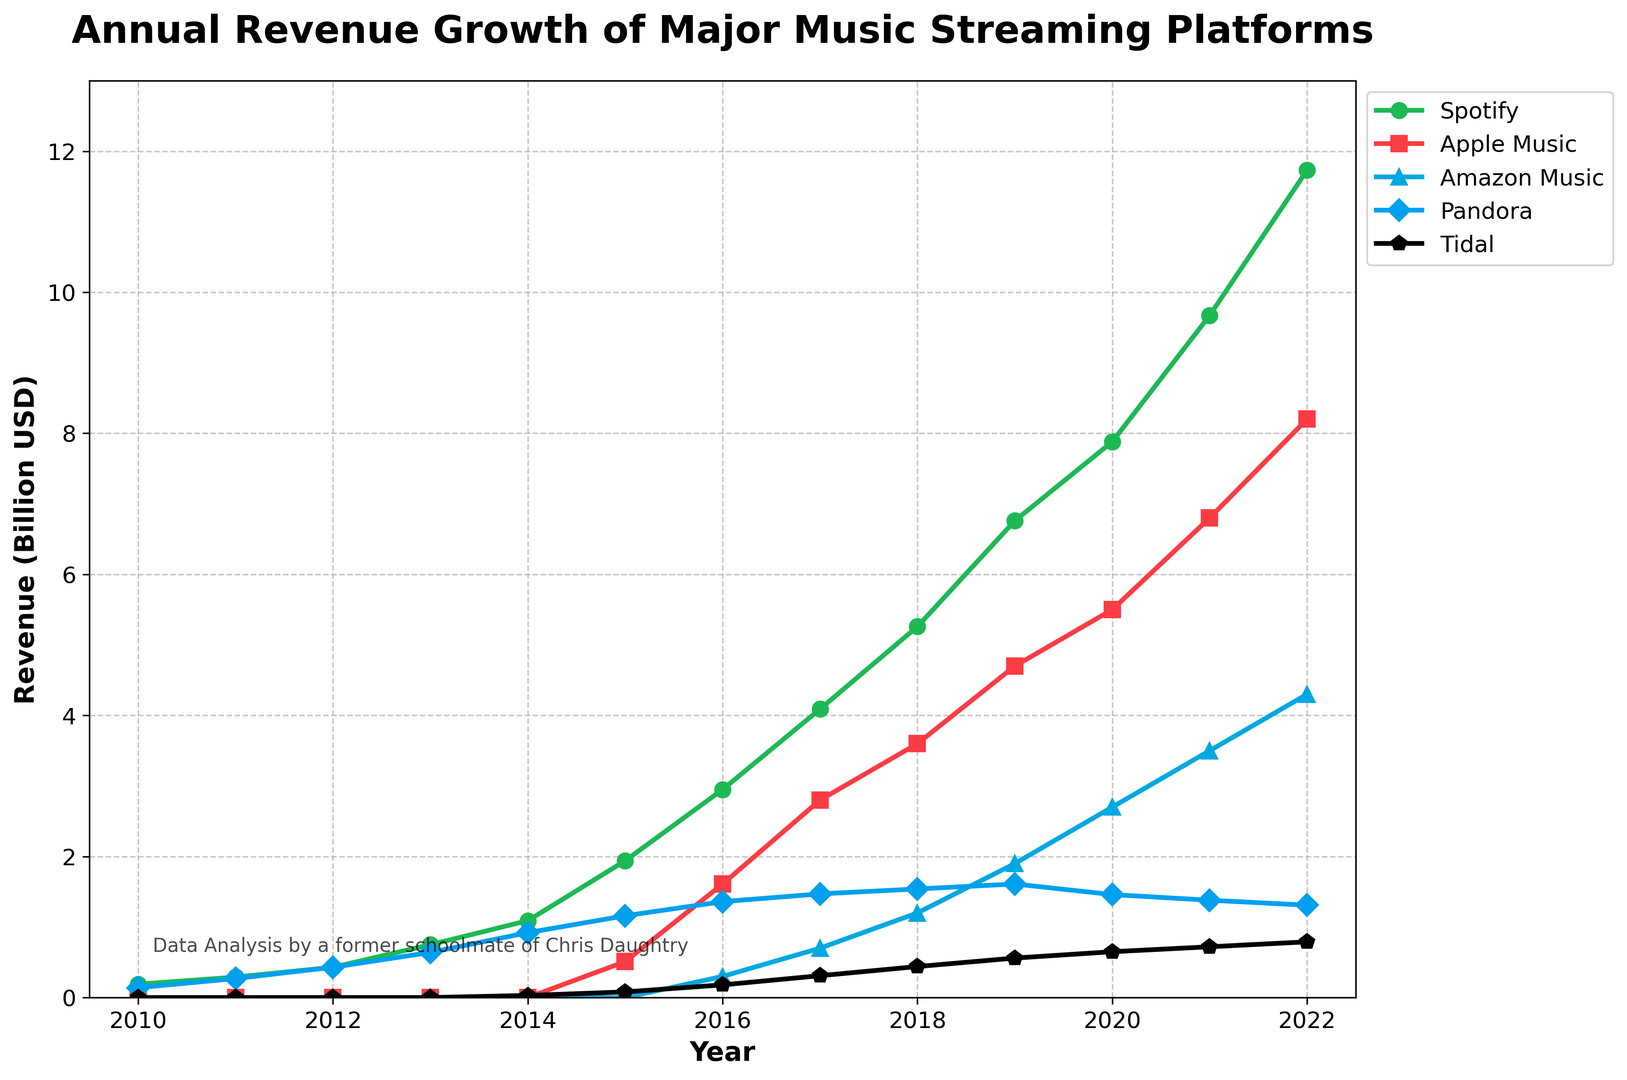Which music streaming platform had the highest revenue in 2022? To find this, look at the end of the plot for the year 2022 and compare the revenue values for each platform. Spotify has the highest revenue, represented by the green line.
Answer: Spotify Between which years did Apple Music see the largest increase in annual revenue? By examining Apple Music's red line, I can see the biggest jump happens between 2015 and 2016, increasing from 0.51 billion to 1.61 billion USD.
Answer: 2015-2016 What is the combined revenue of Spotify and Apple Music in 2021? For 2021, Spotify's revenue is 9.67 billion USD and Apple Music's revenue is 6.8 billion USD. Adding them gives 9.67 + 6.8 = 16.47 billion USD.
Answer: 16.47 billion USD How does Pandora's revenue in 2022 compare to its revenue in 2010? In 2010, Pandora had a revenue of 0.14 billion USD, and in 2022 it was 1.31 billion USD. Pandora's revenue increased by 1.31 - 0.14 = 1.17 billion USD from 2010 to 2022.
Answer: 1.17 billion USD increase Which year did Amazon Music first surpass 2 billion USD in revenue? By following Amazon Music's blue line, I can see that it first crosses the 2 billion USD mark in the year 2020, with a revenue of 2.7 billion USD.
Answer: 2020 What's the average revenue for Tidal from 2015 to 2022? Tidal's revenues from 2015 to 2022 are 0.08, 0.18, 0.31, 0.44, 0.56, 0.65, 0.72, and 0.79 billion USD, respectively. Summing these, 0.08 + 0.18 + 0.31 + 0.44 + 0.56 + 0.65 + 0.72 + 0.79 = 3.73. Dividing by 8 gives an average of 3.73 / 8 = 0.46625 billion USD.
Answer: 0.47 billion USD Which platform showed the most consistent revenue growth over the years? Analyzing the slopes of all lines, Spotify shows the most consistent year-on-year growth with a steadily rising green line from 2010 to 2022.
Answer: Spotify What year did Spotify's revenue first exceed 5 billion USD? By following Spotify's green line, I can see it first surpasses 5 billion USD in the year 2018 with a revenue of 5.26 billion USD.
Answer: 2018 How many platforms had revenues listed every year since 2010? Only Spotify and Pandora have revenues listed every year from 2010 to 2022 as indicated by their continuous lines.
Answer: 2 platforms 